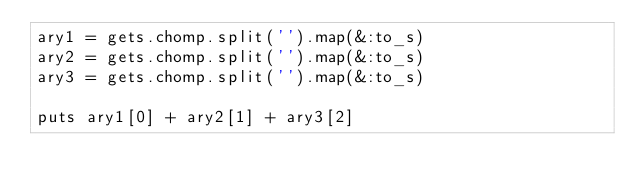Convert code to text. <code><loc_0><loc_0><loc_500><loc_500><_Ruby_>ary1 = gets.chomp.split('').map(&:to_s)
ary2 = gets.chomp.split('').map(&:to_s)
ary3 = gets.chomp.split('').map(&:to_s)

puts ary1[0] + ary2[1] + ary3[2]</code> 